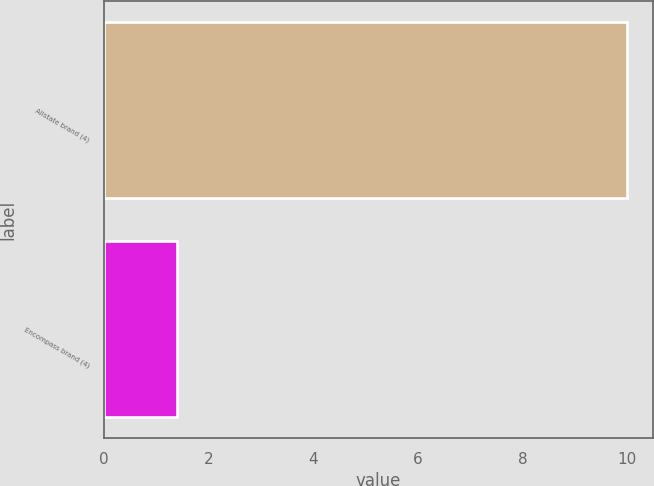<chart> <loc_0><loc_0><loc_500><loc_500><bar_chart><fcel>Allstate brand (4)<fcel>Encompass brand (4)<nl><fcel>10<fcel>1.4<nl></chart> 